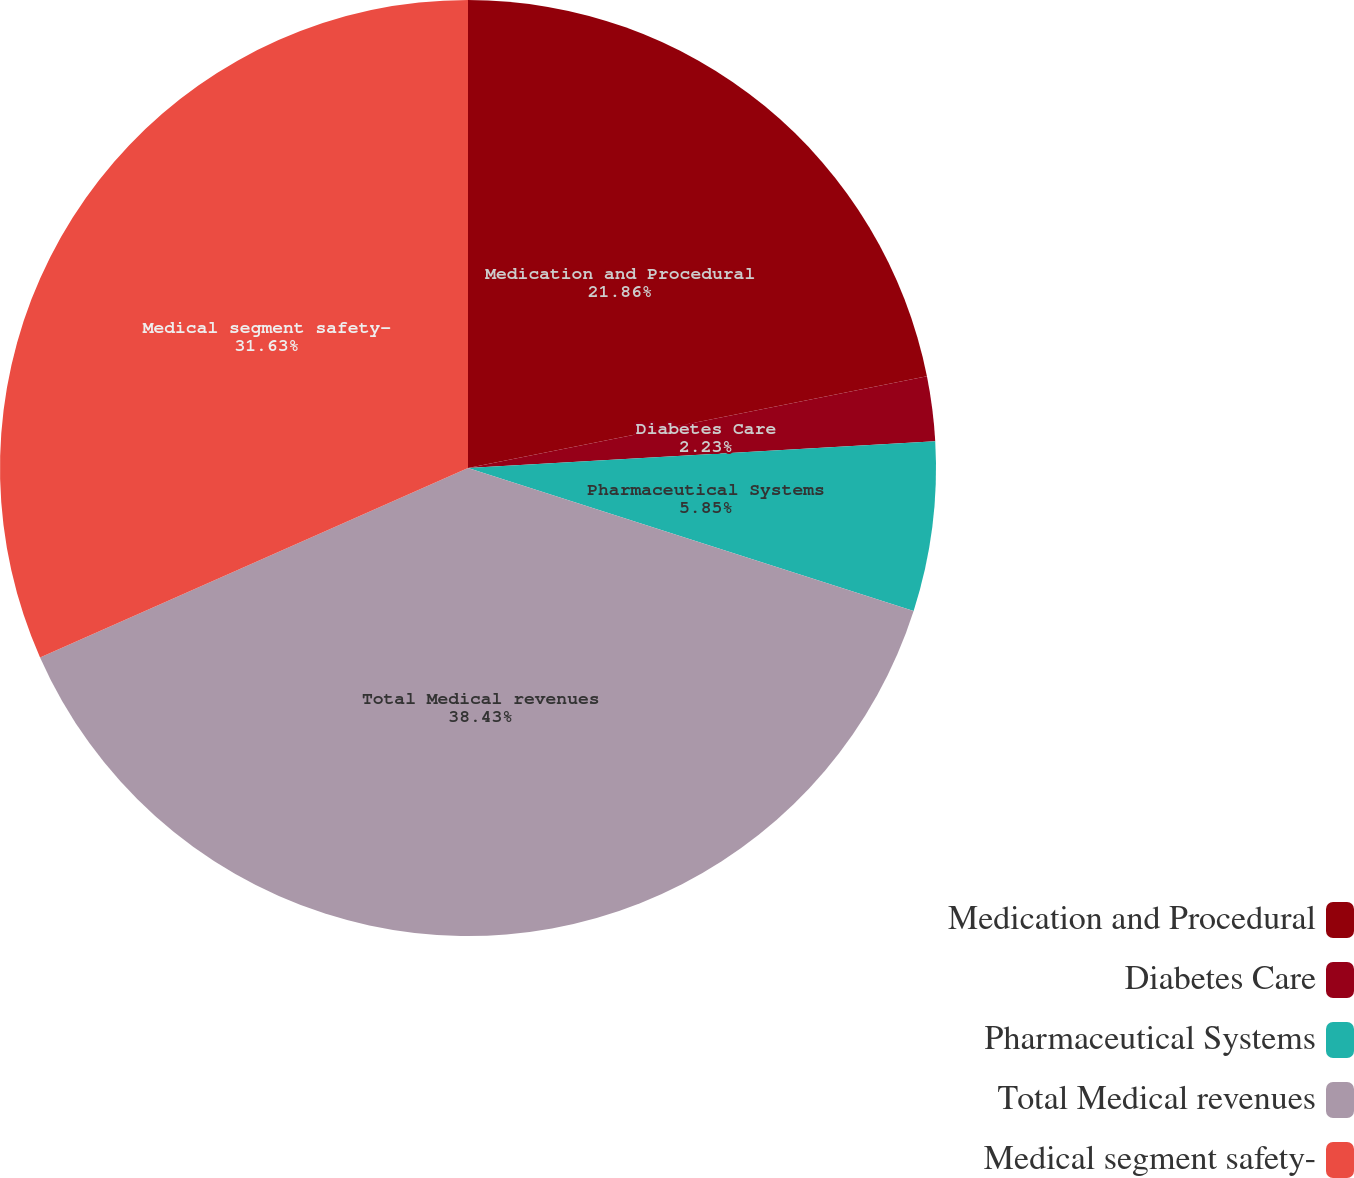Convert chart to OTSL. <chart><loc_0><loc_0><loc_500><loc_500><pie_chart><fcel>Medication and Procedural<fcel>Diabetes Care<fcel>Pharmaceutical Systems<fcel>Total Medical revenues<fcel>Medical segment safety-<nl><fcel>21.86%<fcel>2.23%<fcel>5.85%<fcel>38.42%<fcel>31.63%<nl></chart> 